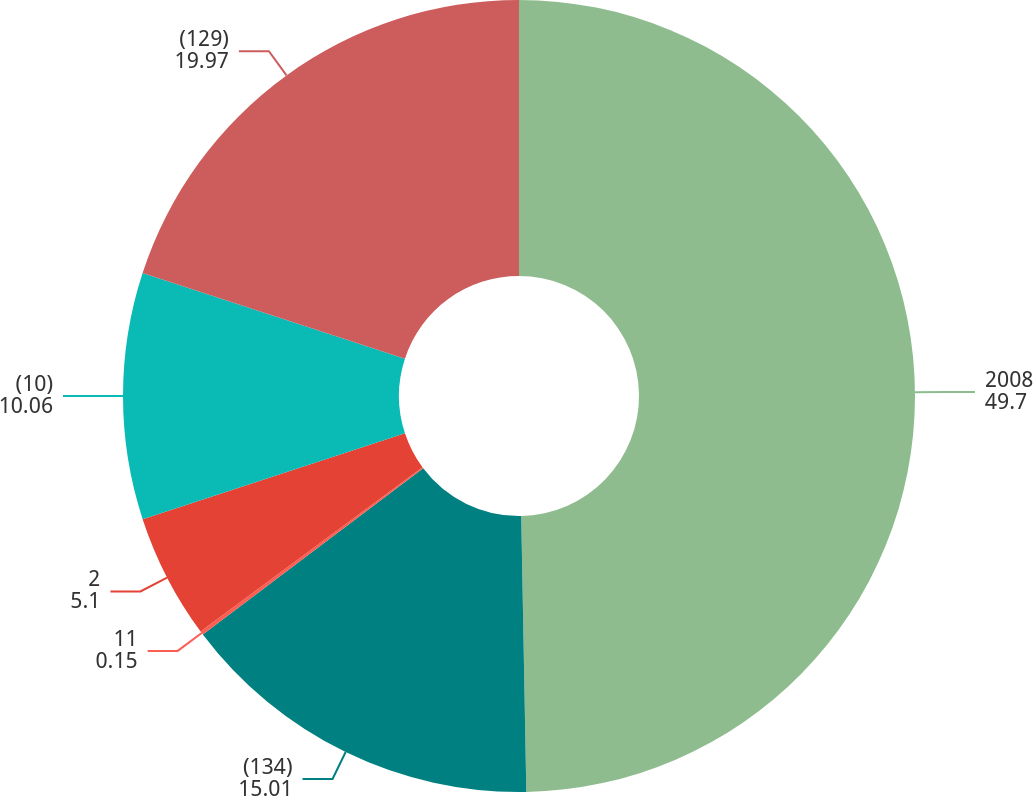<chart> <loc_0><loc_0><loc_500><loc_500><pie_chart><fcel>2008<fcel>(134)<fcel>11<fcel>2<fcel>(10)<fcel>(129)<nl><fcel>49.7%<fcel>15.01%<fcel>0.15%<fcel>5.1%<fcel>10.06%<fcel>19.97%<nl></chart> 